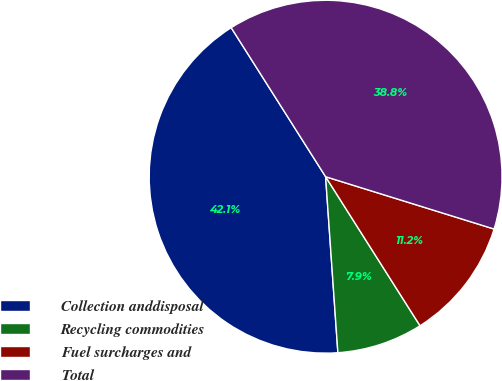<chart> <loc_0><loc_0><loc_500><loc_500><pie_chart><fcel>Collection anddisposal<fcel>Recycling commodities<fcel>Fuel surcharges and<fcel>Total<nl><fcel>42.12%<fcel>7.88%<fcel>11.22%<fcel>38.78%<nl></chart> 